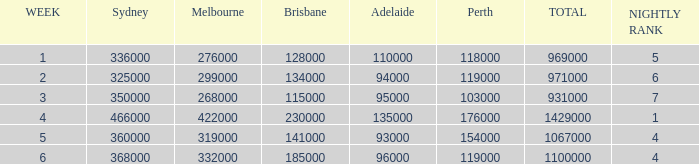When adelaide's rating was 94,000 for a week, what was the rating of brisbane? 134000.0. 